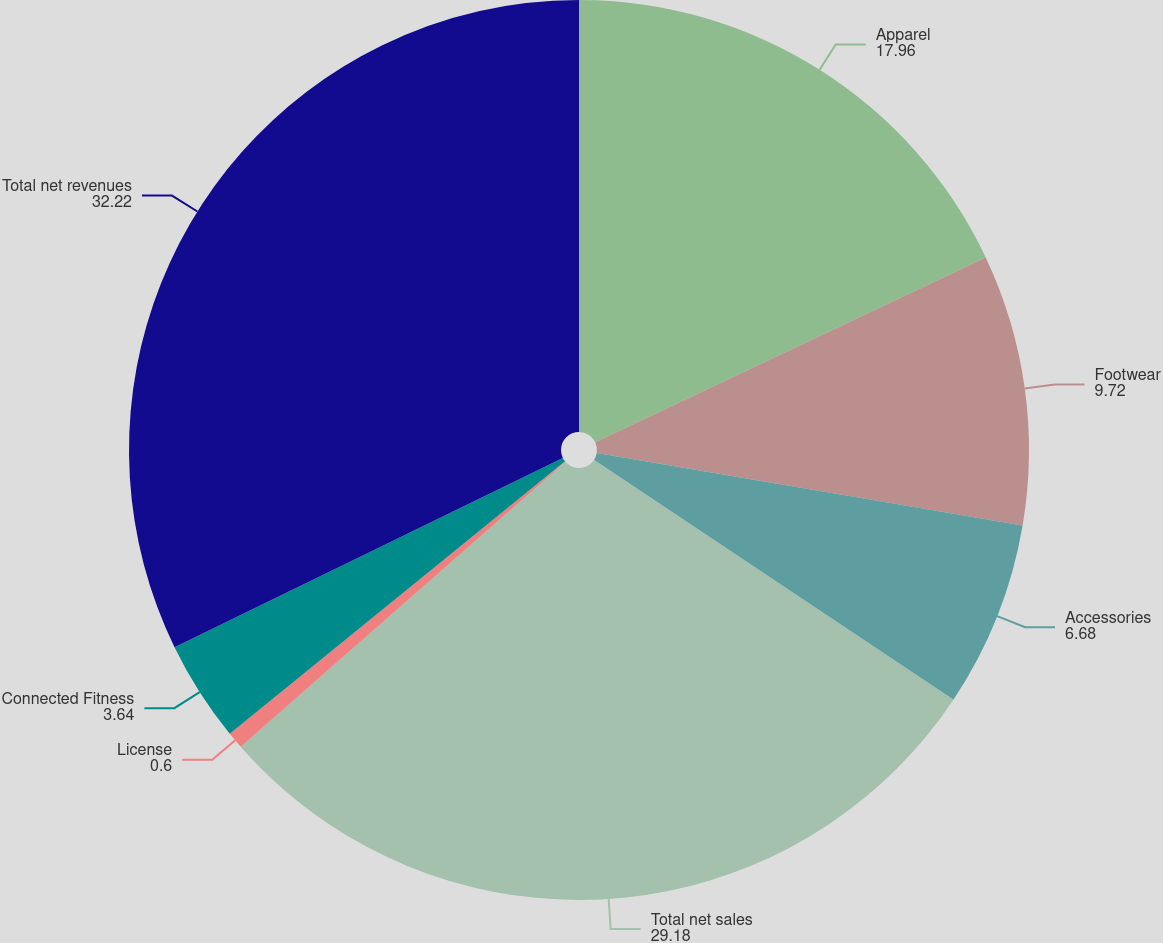Convert chart. <chart><loc_0><loc_0><loc_500><loc_500><pie_chart><fcel>Apparel<fcel>Footwear<fcel>Accessories<fcel>Total net sales<fcel>License<fcel>Connected Fitness<fcel>Total net revenues<nl><fcel>17.96%<fcel>9.72%<fcel>6.68%<fcel>29.18%<fcel>0.6%<fcel>3.64%<fcel>32.22%<nl></chart> 